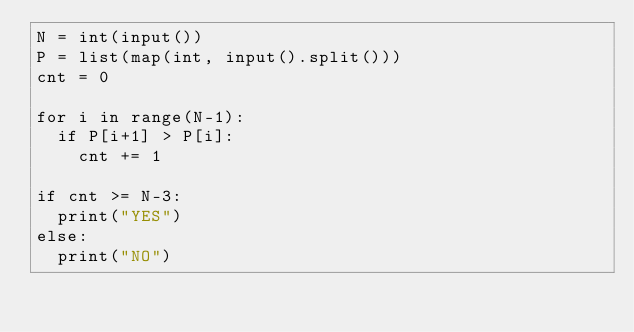Convert code to text. <code><loc_0><loc_0><loc_500><loc_500><_Python_>N = int(input())
P = list(map(int, input().split()))
cnt = 0

for i in range(N-1):
  if P[i+1] > P[i]:
    cnt += 1
    
if cnt >= N-3:
  print("YES")
else:
  print("NO")</code> 